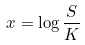Convert formula to latex. <formula><loc_0><loc_0><loc_500><loc_500>x = \log \frac { S } { K }</formula> 